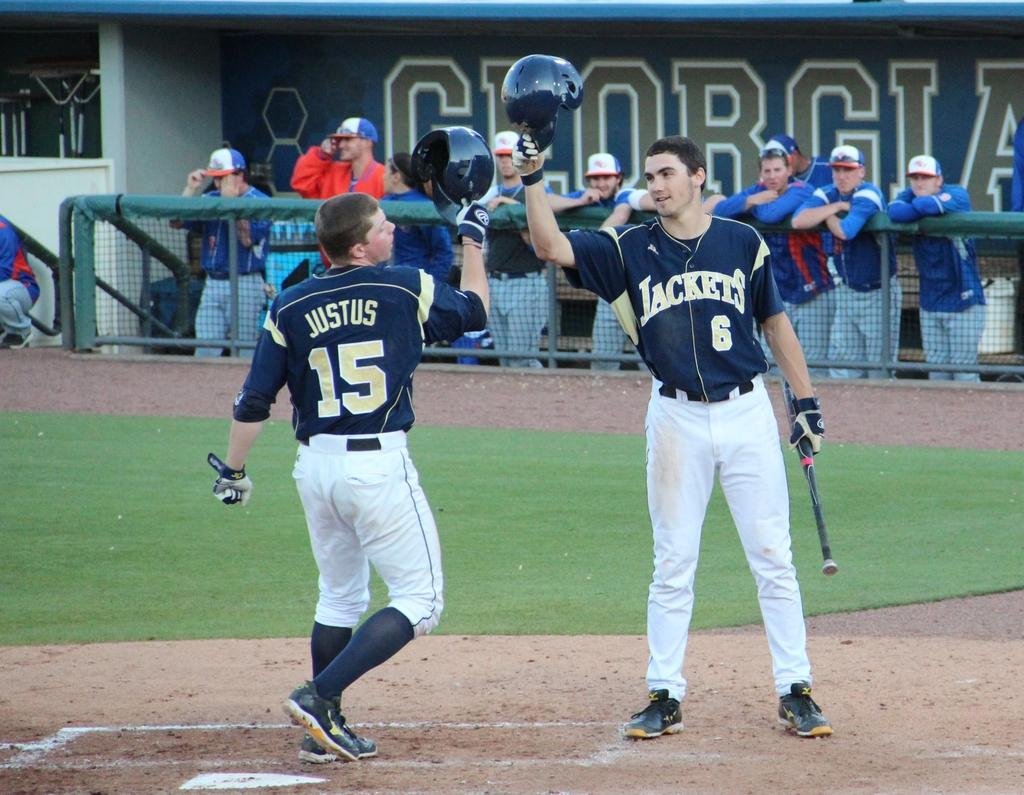Provide a one-sentence caption for the provided image. georgia jackets players celebrating on the baseball field. 